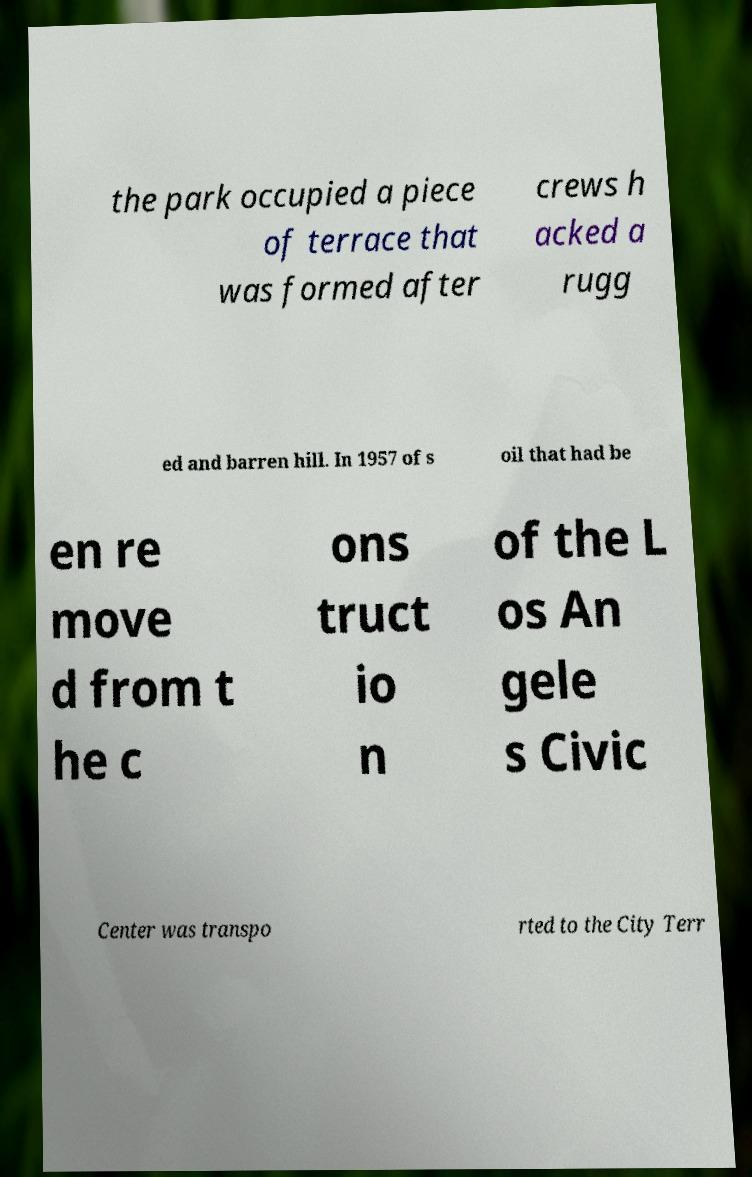There's text embedded in this image that I need extracted. Can you transcribe it verbatim? the park occupied a piece of terrace that was formed after crews h acked a rugg ed and barren hill. In 1957 of s oil that had be en re move d from t he c ons truct io n of the L os An gele s Civic Center was transpo rted to the City Terr 